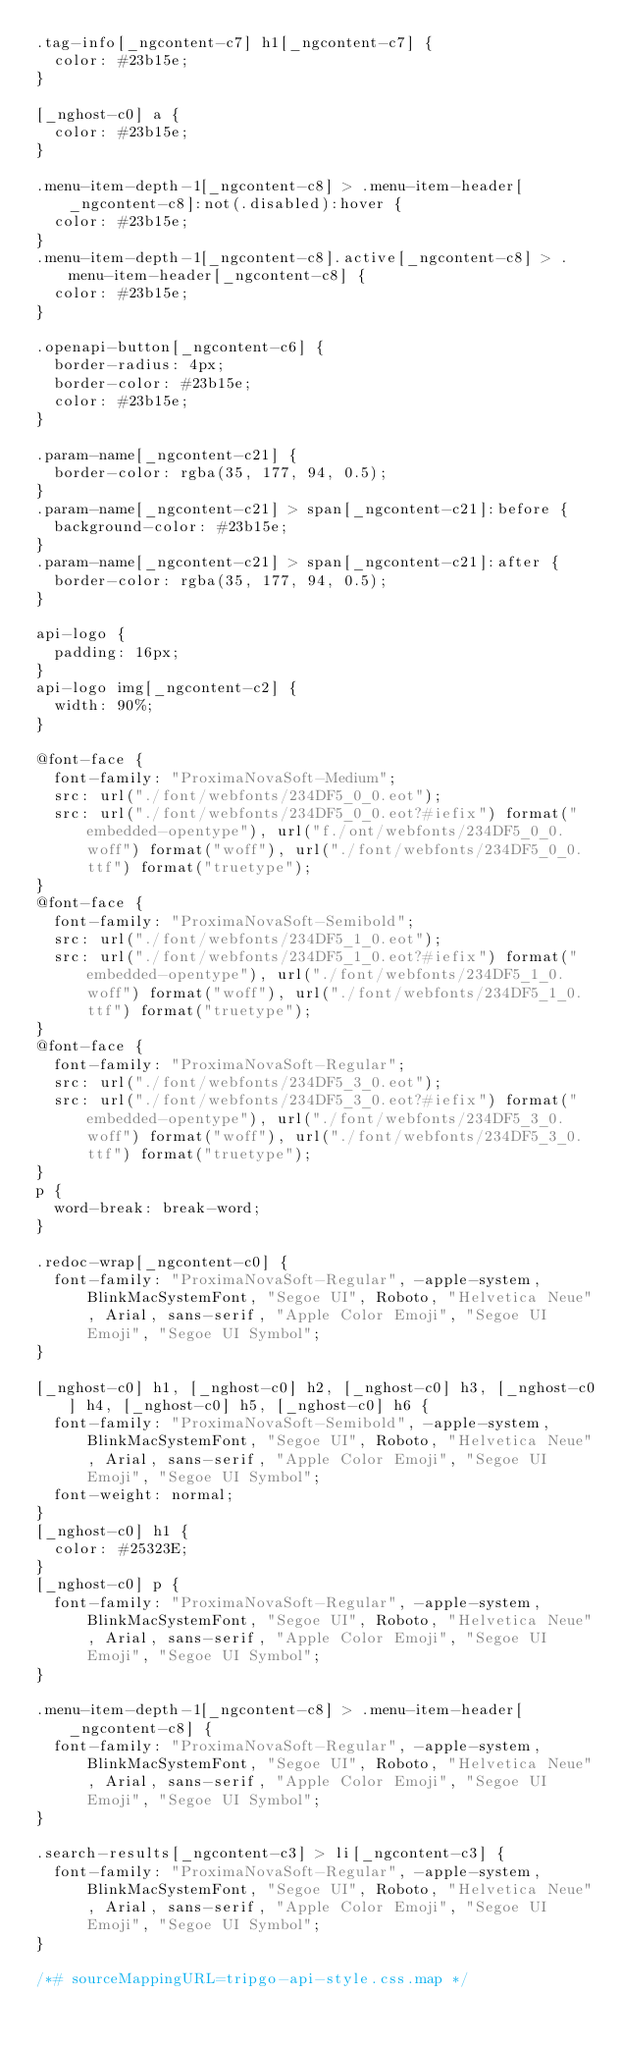Convert code to text. <code><loc_0><loc_0><loc_500><loc_500><_CSS_>.tag-info[_ngcontent-c7] h1[_ngcontent-c7] {
  color: #23b15e;
}

[_nghost-c0] a {
  color: #23b15e;
}

.menu-item-depth-1[_ngcontent-c8] > .menu-item-header[_ngcontent-c8]:not(.disabled):hover {
  color: #23b15e;
}
.menu-item-depth-1[_ngcontent-c8].active[_ngcontent-c8] > .menu-item-header[_ngcontent-c8] {
  color: #23b15e;
}

.openapi-button[_ngcontent-c6] {
  border-radius: 4px;
  border-color: #23b15e;
  color: #23b15e;
}

.param-name[_ngcontent-c21] {
  border-color: rgba(35, 177, 94, 0.5);
}
.param-name[_ngcontent-c21] > span[_ngcontent-c21]:before {
  background-color: #23b15e;
}
.param-name[_ngcontent-c21] > span[_ngcontent-c21]:after {
  border-color: rgba(35, 177, 94, 0.5);
}

api-logo {
  padding: 16px;
}
api-logo img[_ngcontent-c2] {
  width: 90%;
}

@font-face {
  font-family: "ProximaNovaSoft-Medium";
  src: url("./font/webfonts/234DF5_0_0.eot");
  src: url("./font/webfonts/234DF5_0_0.eot?#iefix") format("embedded-opentype"), url("f./ont/webfonts/234DF5_0_0.woff") format("woff"), url("./font/webfonts/234DF5_0_0.ttf") format("truetype");
}
@font-face {
  font-family: "ProximaNovaSoft-Semibold";
  src: url("./font/webfonts/234DF5_1_0.eot");
  src: url("./font/webfonts/234DF5_1_0.eot?#iefix") format("embedded-opentype"), url("./font/webfonts/234DF5_1_0.woff") format("woff"), url("./font/webfonts/234DF5_1_0.ttf") format("truetype");
}
@font-face {
  font-family: "ProximaNovaSoft-Regular";
  src: url("./font/webfonts/234DF5_3_0.eot");
  src: url("./font/webfonts/234DF5_3_0.eot?#iefix") format("embedded-opentype"), url("./font/webfonts/234DF5_3_0.woff") format("woff"), url("./font/webfonts/234DF5_3_0.ttf") format("truetype");
}
p {
  word-break: break-word;
}

.redoc-wrap[_ngcontent-c0] {
  font-family: "ProximaNovaSoft-Regular", -apple-system, BlinkMacSystemFont, "Segoe UI", Roboto, "Helvetica Neue", Arial, sans-serif, "Apple Color Emoji", "Segoe UI Emoji", "Segoe UI Symbol";
}

[_nghost-c0] h1, [_nghost-c0] h2, [_nghost-c0] h3, [_nghost-c0] h4, [_nghost-c0] h5, [_nghost-c0] h6 {
  font-family: "ProximaNovaSoft-Semibold", -apple-system, BlinkMacSystemFont, "Segoe UI", Roboto, "Helvetica Neue", Arial, sans-serif, "Apple Color Emoji", "Segoe UI Emoji", "Segoe UI Symbol";
  font-weight: normal;
}
[_nghost-c0] h1 {
  color: #25323E;
}
[_nghost-c0] p {
  font-family: "ProximaNovaSoft-Regular", -apple-system, BlinkMacSystemFont, "Segoe UI", Roboto, "Helvetica Neue", Arial, sans-serif, "Apple Color Emoji", "Segoe UI Emoji", "Segoe UI Symbol";
}

.menu-item-depth-1[_ngcontent-c8] > .menu-item-header[_ngcontent-c8] {
  font-family: "ProximaNovaSoft-Regular", -apple-system, BlinkMacSystemFont, "Segoe UI", Roboto, "Helvetica Neue", Arial, sans-serif, "Apple Color Emoji", "Segoe UI Emoji", "Segoe UI Symbol";
}

.search-results[_ngcontent-c3] > li[_ngcontent-c3] {
  font-family: "ProximaNovaSoft-Regular", -apple-system, BlinkMacSystemFont, "Segoe UI", Roboto, "Helvetica Neue", Arial, sans-serif, "Apple Color Emoji", "Segoe UI Emoji", "Segoe UI Symbol";
}

/*# sourceMappingURL=tripgo-api-style.css.map */
</code> 